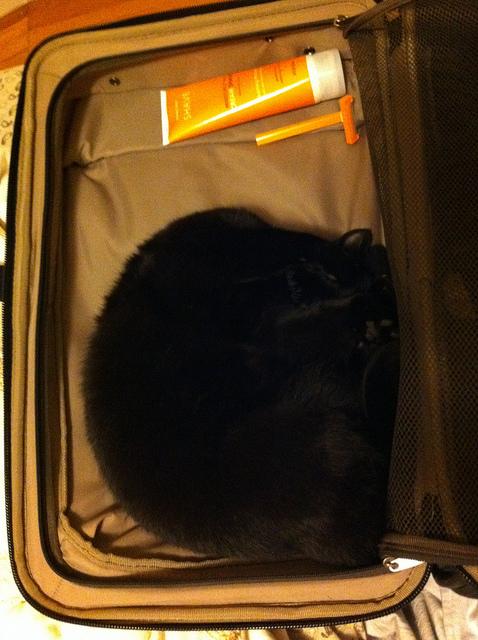Is the animal sleeping?
Keep it brief. Yes. What kind of cat is shown?
Short answer required. Black. What is in the suitcase?
Give a very brief answer. Cat. How many items are in the bag?
Concise answer only. 3. Is the razor expensive?
Quick response, please. No. 